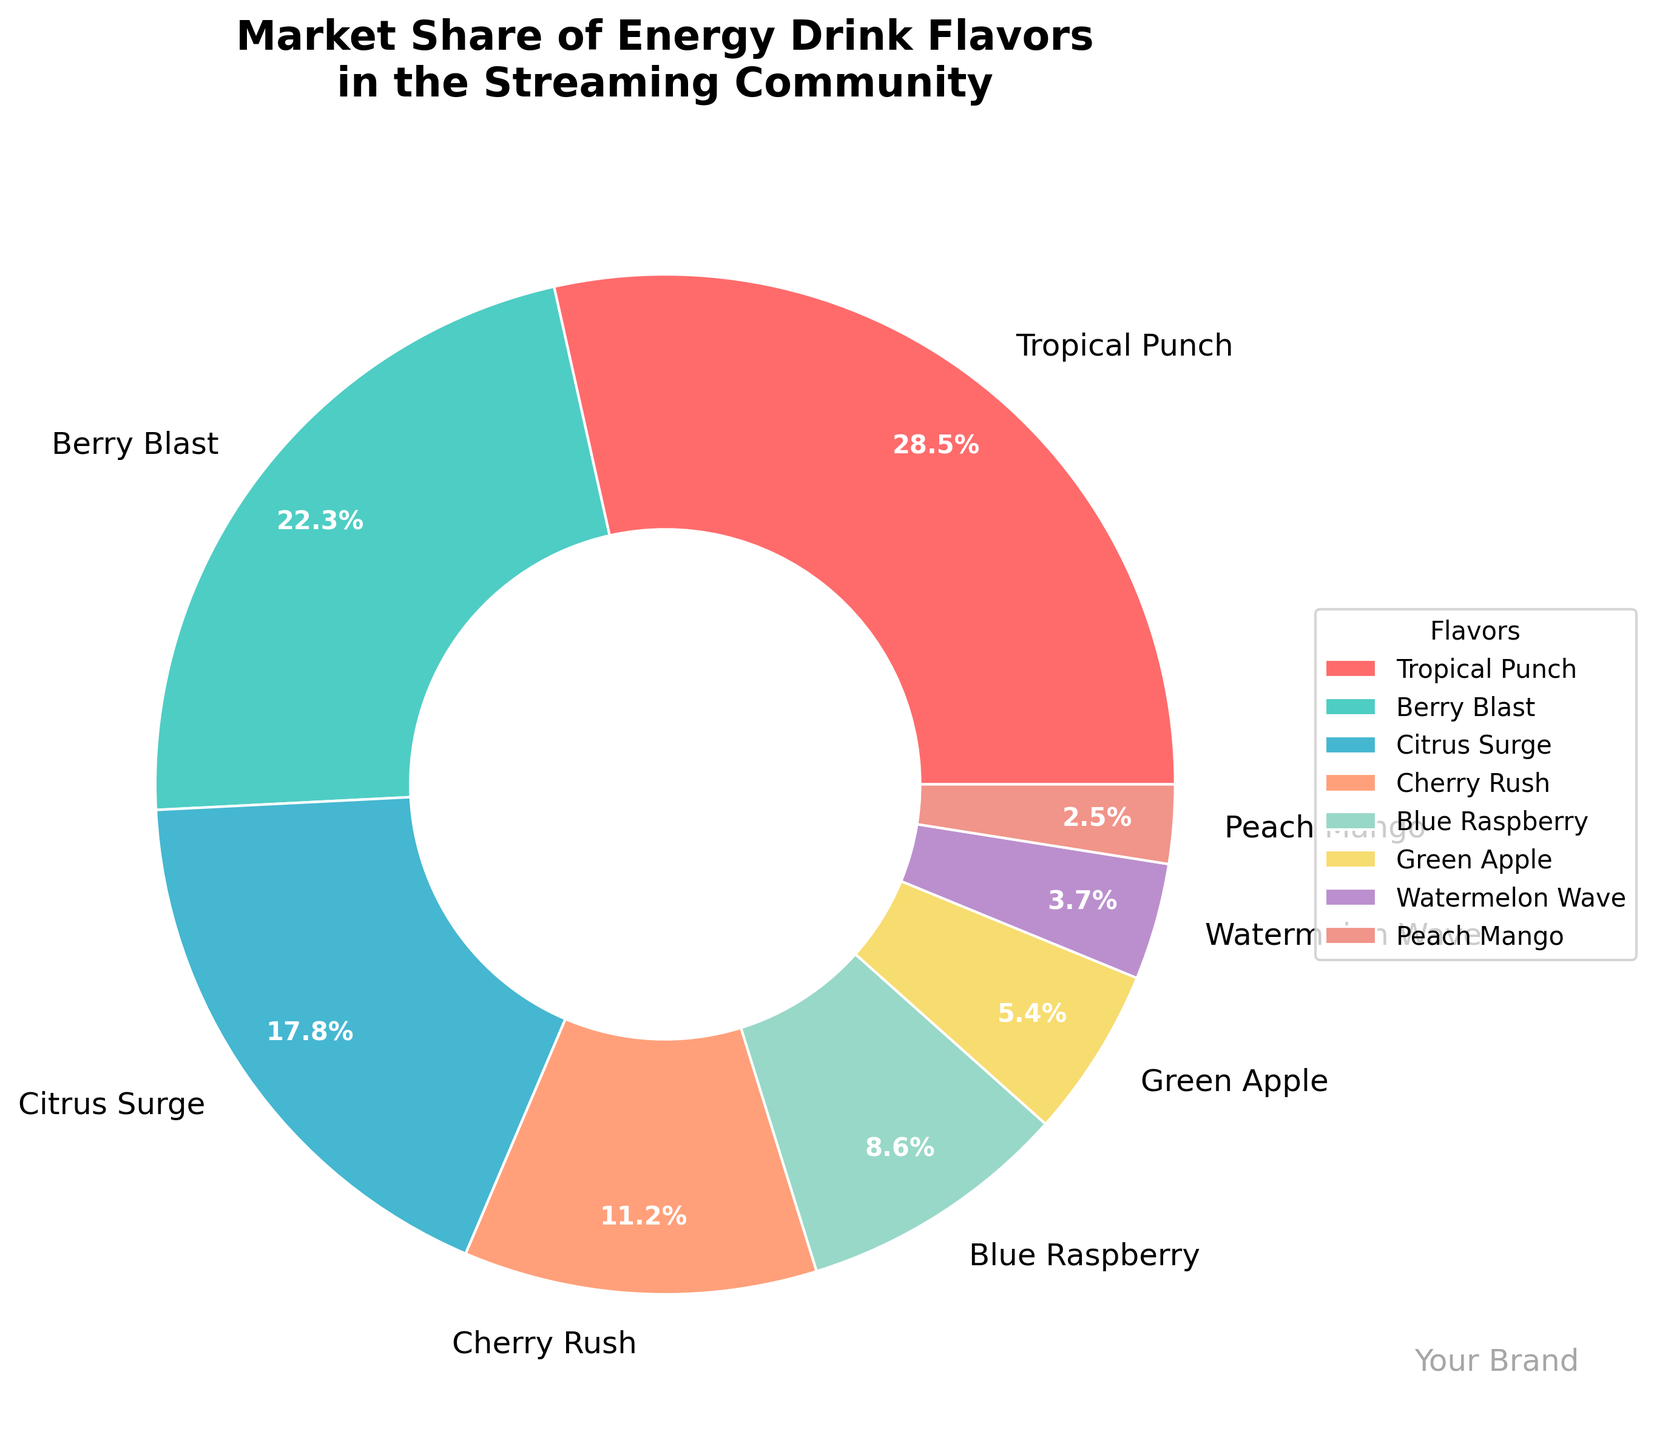Which flavor holds the largest market share? From the pie chart, the slice labeled "Tropical Punch" is the largest. This shows that Tropical Punch holds the largest share.
Answer: Tropical Punch How much more market share does Berry Blast have compared to Cherry Rush? From the chart, Berry Blast has a market share of 22.3% and Cherry Rush has 11.2%. The difference is 22.3% - 11.2% = 11.1%.
Answer: 11.1% What is the combined market share of Citrus Surge and Blue Raspberry? From the chart, Citrus Surge has a market share of 17.8% and Blue Raspberry has 8.6%. Adding these together gives 17.8% + 8.6% = 26.4%.
Answer: 26.4% Is the market share of Tropical Punch more than double that of Watermelon Wave? Tropical Punch has a market share of 28.5% and Watermelon Wave has 3.7%. Doubling Watermelon Wave's market share is 3.7% * 2 = 7.4%. Tropical Punch's 28.5% is indeed more than 7.4%.
Answer: Yes Which flavor has the smallest market share and what is it? From the chart, the smallest slice is labeled "Peach Mango," indicating it has the smallest market share. The percentage is 2.5%.
Answer: Peach Mango, 2.5% Compare the market shares of Cherry Rush and Green Apple. Which one is greater and by how much? Cherry Rush has a market share of 11.2% while Green Apple has 5.4%. The difference is 11.2% - 5.4% = 5.8%. Cherry Rush has a greater market share by 5.8%.
Answer: Cherry Rush, 5.8% What is the total market share of flavors that have less than 10% each? The acceptable flavors are Cherry Rush (11.2% not included), Blue Raspberry (8.6%), Green Apple (5.4%), Watermelon Wave (3.7%), and Peach Mango (2.5%). Adding these gives 8.6% + 5.4% + 3.7% + 2.5% = 20.2%.
Answer: 20.2% What proportion of the market share do the top three flavors hold? The top three flavors by market share are Tropical Punch (28.5%), Berry Blast (22.3%), and Citrus Surge (17.8%). Adding these gives 28.5% + 22.3% + 17.8% = 68.6%.
Answer: 68.6% Which flavor has a market share closest to 10%? From the chart, Cherry Rush has a market share of 11.2%, which is closest to 10%.
Answer: Cherry Rush By what percentage does Tropical Punch lead over Berry Blast? Tropical Punch has a market share of 28.5% and Berry Blast has 22.3%. The difference is 28.5% - 22.3% = 6.2%. To find the percentage lead, (6.2% / 22.3%) * 100 = 27.8%.
Answer: 27.8% 